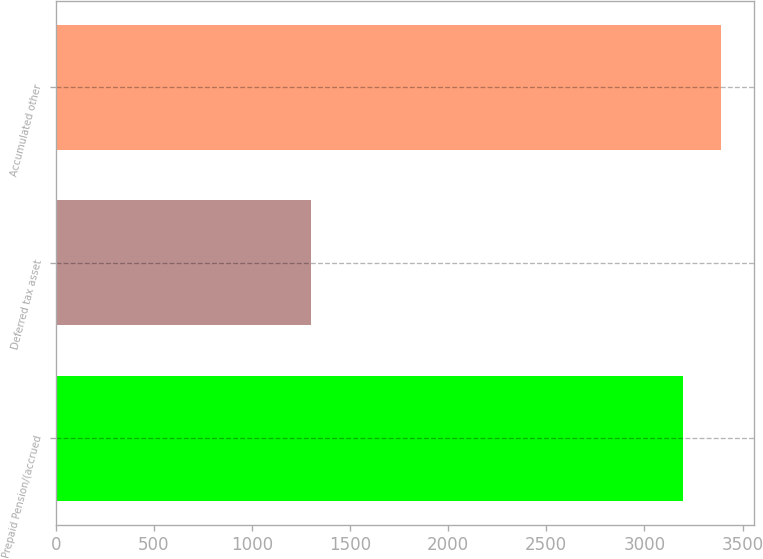Convert chart. <chart><loc_0><loc_0><loc_500><loc_500><bar_chart><fcel>Prepaid Pension/(accrued<fcel>Deferred tax asset<fcel>Accumulated other<nl><fcel>3199<fcel>1300<fcel>3390.8<nl></chart> 